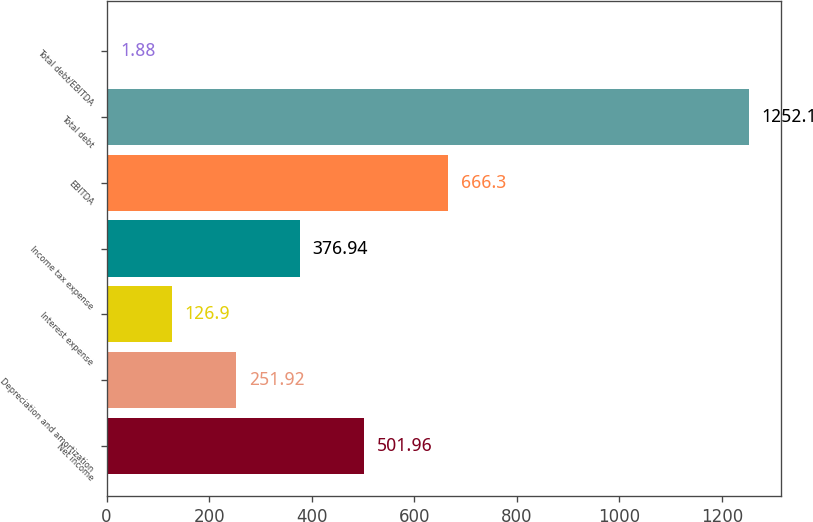Convert chart to OTSL. <chart><loc_0><loc_0><loc_500><loc_500><bar_chart><fcel>Net income<fcel>Depreciation and amortization<fcel>Interest expense<fcel>Income tax expense<fcel>EBITDA<fcel>Total debt<fcel>Total debt/EBITDA<nl><fcel>501.96<fcel>251.92<fcel>126.9<fcel>376.94<fcel>666.3<fcel>1252.1<fcel>1.88<nl></chart> 